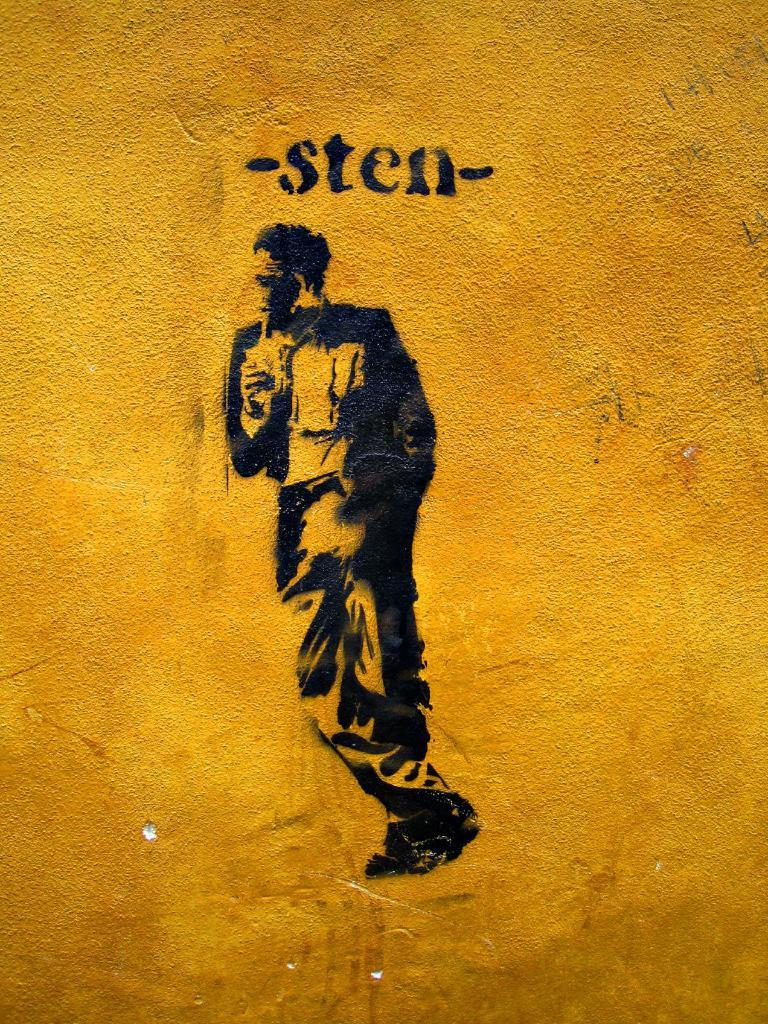<image>
Describe the image concisely. A leaning man has the word sten printed above him. 